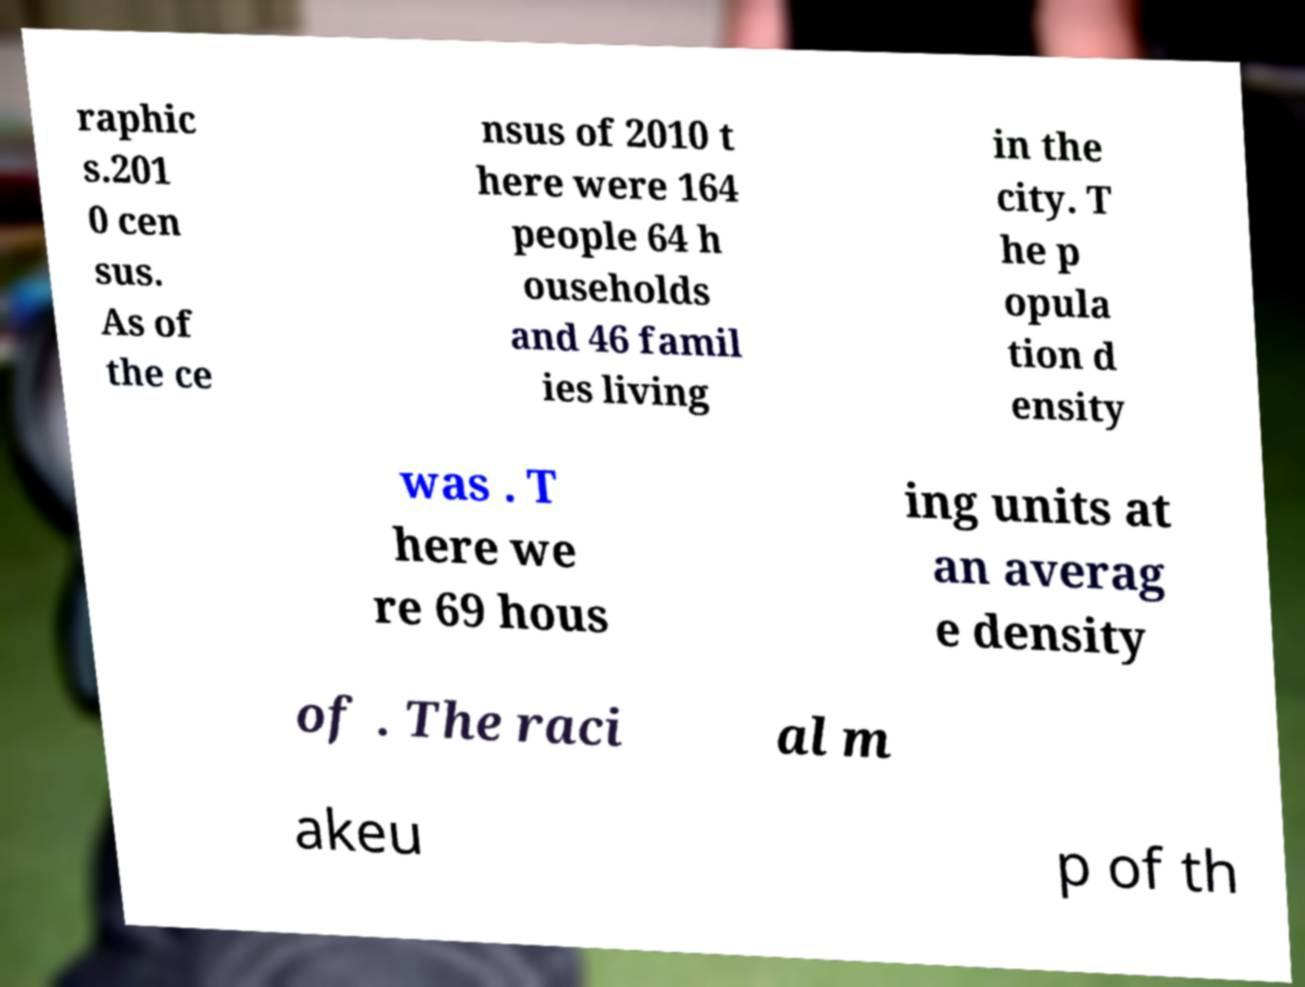Can you read and provide the text displayed in the image?This photo seems to have some interesting text. Can you extract and type it out for me? raphic s.201 0 cen sus. As of the ce nsus of 2010 t here were 164 people 64 h ouseholds and 46 famil ies living in the city. T he p opula tion d ensity was . T here we re 69 hous ing units at an averag e density of . The raci al m akeu p of th 